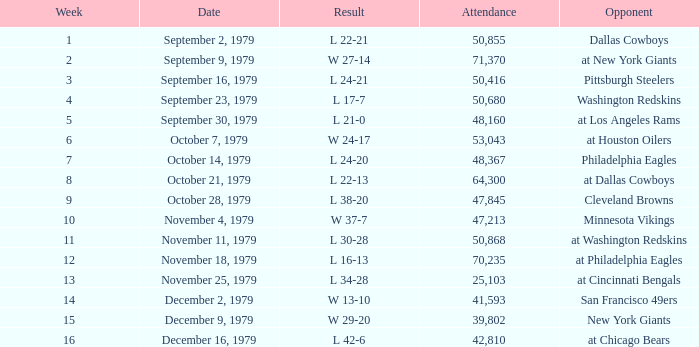What result in a week over 2 occurred with an attendance greater than 53,043 on November 18, 1979? L 16-13. 